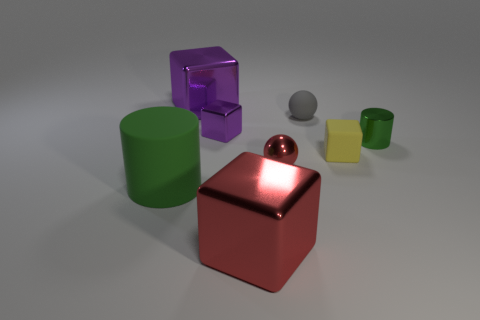What can you infer about the lighting in the scene? The scene is softly lit, with shadows indicating the light source is coming from the upper left. The reflections on the red sphere and the metal cube, as well as the shadow patterns on the ground, suggest a single, diffused light source—perhaps an overhead soft light or a window diffusing daylight. 